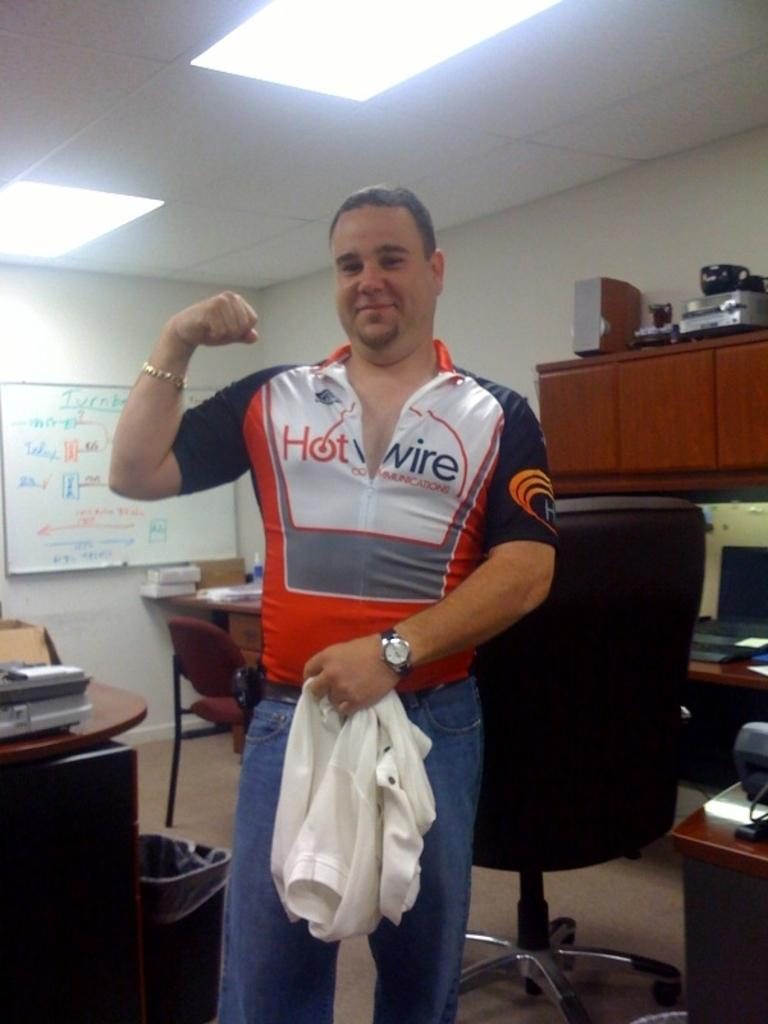<image>
Give a short and clear explanation of the subsequent image. A man with a Hot Wire shirt on 